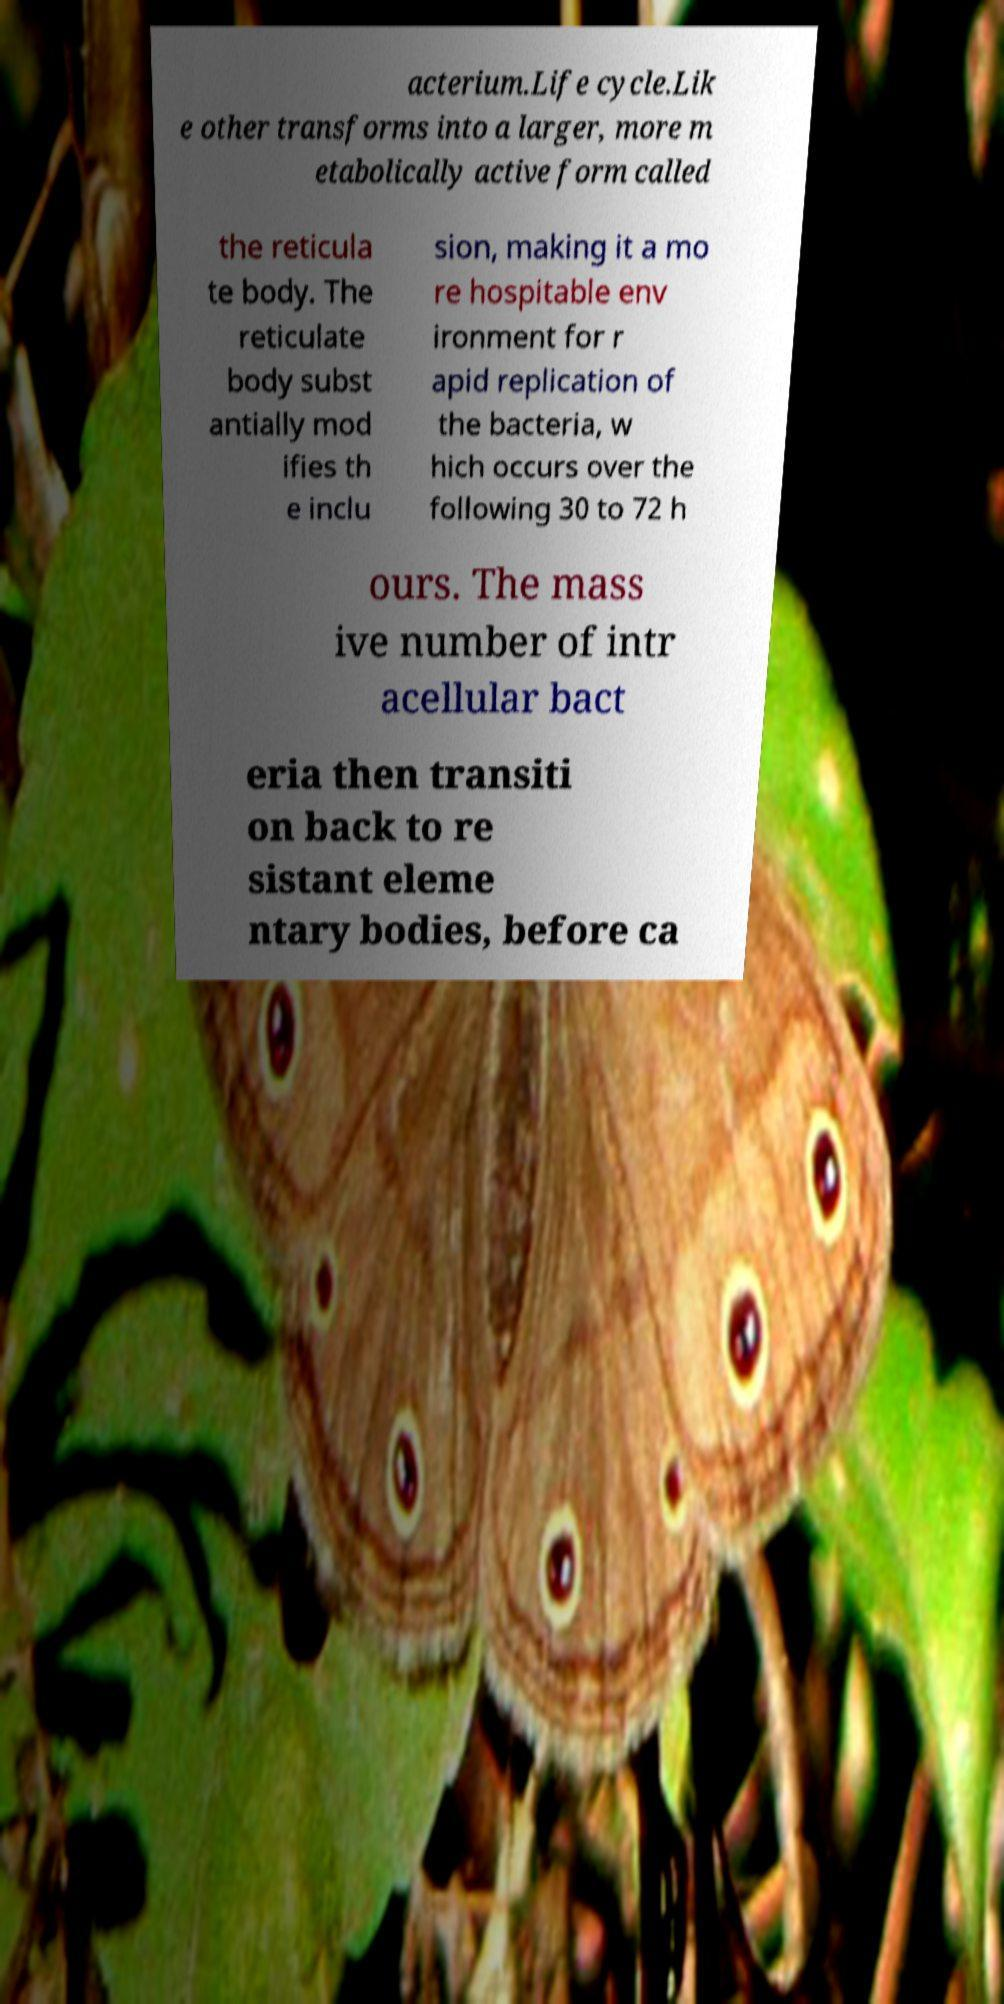Can you accurately transcribe the text from the provided image for me? acterium.Life cycle.Lik e other transforms into a larger, more m etabolically active form called the reticula te body. The reticulate body subst antially mod ifies th e inclu sion, making it a mo re hospitable env ironment for r apid replication of the bacteria, w hich occurs over the following 30 to 72 h ours. The mass ive number of intr acellular bact eria then transiti on back to re sistant eleme ntary bodies, before ca 